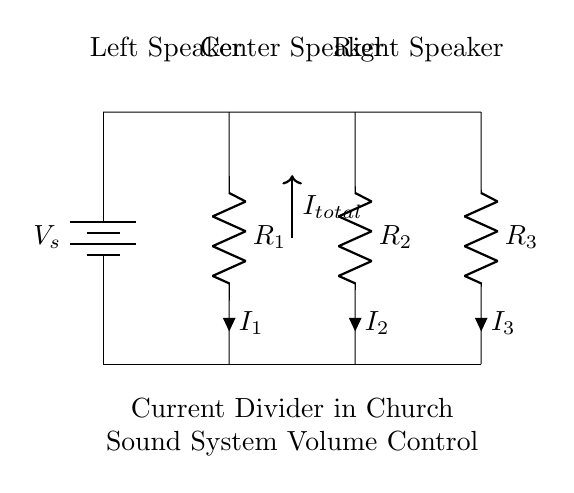What is the total current in the circuit? The total current is indicated by the arrow labeled I_total in the diagram. As the total current is the sum of the currents through the individual resistors, it represents the current entering the parallel resistors.
Answer: I_total How many resistors are in the circuit? There are three resistors shown in the diagram, labeled R1, R2, and R3. Each resistor is a component through which current can flow.
Answer: Three What do the resistors represent in this circuit? The resistors represent the individual speakers in the sound system. Each speaker's resistance affects the current flow, thereby controlling the volume for that speaker.
Answer: Speakers Which resistor has the highest resistance value? The circuit diagram does not specify the resistance values, so it's unclear; however, they could be ordered or labeled if provided. In a typical current divider, the largest resistance would draw the least current.
Answer: Unknown What happens to the current as it passes through the resistors? As current passes through each resistor, it divides based on the resistance value. This division results in varying current levels through each speaker, affecting their volume output.
Answer: Divides If R1 is removed, what will happen to the current through R2 and R3? Removing R1 will increase the total current flowing through the circuit, which would cause R2 and R3 to receive a higher current as they would now share the total current without R1 contributing to the division.
Answer: Increases 